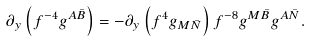Convert formula to latex. <formula><loc_0><loc_0><loc_500><loc_500>\partial _ { y } \left ( f ^ { - 4 } g ^ { A \bar { B } } \right ) = - \partial _ { y } \left ( f ^ { 4 } g _ { M \bar { N } } \right ) f ^ { - 8 } g ^ { M \bar { B } } g ^ { A \bar { N } } .</formula> 